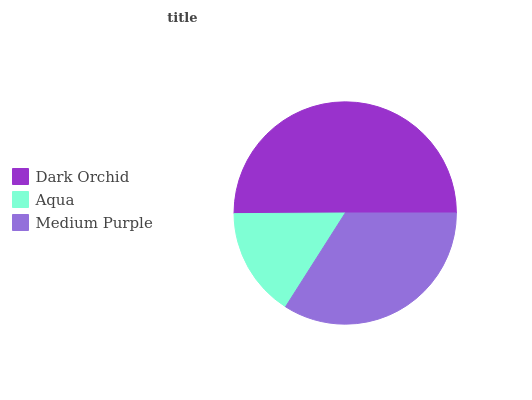Is Aqua the minimum?
Answer yes or no. Yes. Is Dark Orchid the maximum?
Answer yes or no. Yes. Is Medium Purple the minimum?
Answer yes or no. No. Is Medium Purple the maximum?
Answer yes or no. No. Is Medium Purple greater than Aqua?
Answer yes or no. Yes. Is Aqua less than Medium Purple?
Answer yes or no. Yes. Is Aqua greater than Medium Purple?
Answer yes or no. No. Is Medium Purple less than Aqua?
Answer yes or no. No. Is Medium Purple the high median?
Answer yes or no. Yes. Is Medium Purple the low median?
Answer yes or no. Yes. Is Aqua the high median?
Answer yes or no. No. Is Dark Orchid the low median?
Answer yes or no. No. 